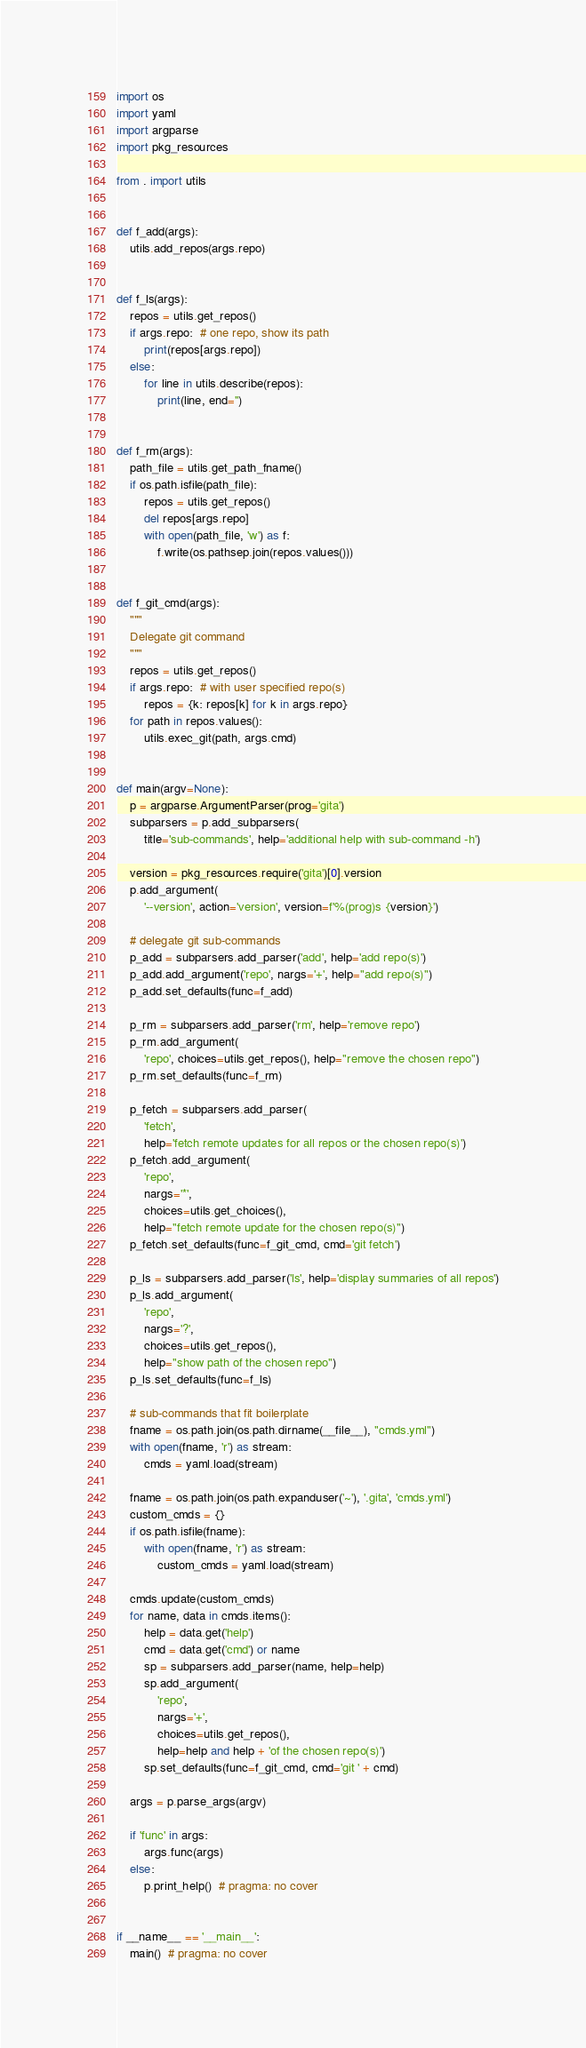<code> <loc_0><loc_0><loc_500><loc_500><_Python_>import os
import yaml
import argparse
import pkg_resources

from . import utils


def f_add(args):
    utils.add_repos(args.repo)


def f_ls(args):
    repos = utils.get_repos()
    if args.repo:  # one repo, show its path
        print(repos[args.repo])
    else:
        for line in utils.describe(repos):
            print(line, end='')


def f_rm(args):
    path_file = utils.get_path_fname()
    if os.path.isfile(path_file):
        repos = utils.get_repos()
        del repos[args.repo]
        with open(path_file, 'w') as f:
            f.write(os.pathsep.join(repos.values()))


def f_git_cmd(args):
    """
    Delegate git command
    """
    repos = utils.get_repos()
    if args.repo:  # with user specified repo(s)
        repos = {k: repos[k] for k in args.repo}
    for path in repos.values():
        utils.exec_git(path, args.cmd)


def main(argv=None):
    p = argparse.ArgumentParser(prog='gita')
    subparsers = p.add_subparsers(
        title='sub-commands', help='additional help with sub-command -h')

    version = pkg_resources.require('gita')[0].version
    p.add_argument(
        '--version', action='version', version=f'%(prog)s {version}')

    # delegate git sub-commands
    p_add = subparsers.add_parser('add', help='add repo(s)')
    p_add.add_argument('repo', nargs='+', help="add repo(s)")
    p_add.set_defaults(func=f_add)

    p_rm = subparsers.add_parser('rm', help='remove repo')
    p_rm.add_argument(
        'repo', choices=utils.get_repos(), help="remove the chosen repo")
    p_rm.set_defaults(func=f_rm)

    p_fetch = subparsers.add_parser(
        'fetch',
        help='fetch remote updates for all repos or the chosen repo(s)')
    p_fetch.add_argument(
        'repo',
        nargs='*',
        choices=utils.get_choices(),
        help="fetch remote update for the chosen repo(s)")
    p_fetch.set_defaults(func=f_git_cmd, cmd='git fetch')

    p_ls = subparsers.add_parser('ls', help='display summaries of all repos')
    p_ls.add_argument(
        'repo',
        nargs='?',
        choices=utils.get_repos(),
        help="show path of the chosen repo")
    p_ls.set_defaults(func=f_ls)

    # sub-commands that fit boilerplate
    fname = os.path.join(os.path.dirname(__file__), "cmds.yml")
    with open(fname, 'r') as stream:
        cmds = yaml.load(stream)

    fname = os.path.join(os.path.expanduser('~'), '.gita', 'cmds.yml')
    custom_cmds = {}
    if os.path.isfile(fname):
        with open(fname, 'r') as stream:
            custom_cmds = yaml.load(stream)

    cmds.update(custom_cmds)
    for name, data in cmds.items():
        help = data.get('help')
        cmd = data.get('cmd') or name
        sp = subparsers.add_parser(name, help=help)
        sp.add_argument(
            'repo',
            nargs='+',
            choices=utils.get_repos(),
            help=help and help + 'of the chosen repo(s)')
        sp.set_defaults(func=f_git_cmd, cmd='git ' + cmd)

    args = p.parse_args(argv)

    if 'func' in args:
        args.func(args)
    else:
        p.print_help()  # pragma: no cover


if __name__ == '__main__':
    main()  # pragma: no cover
</code> 